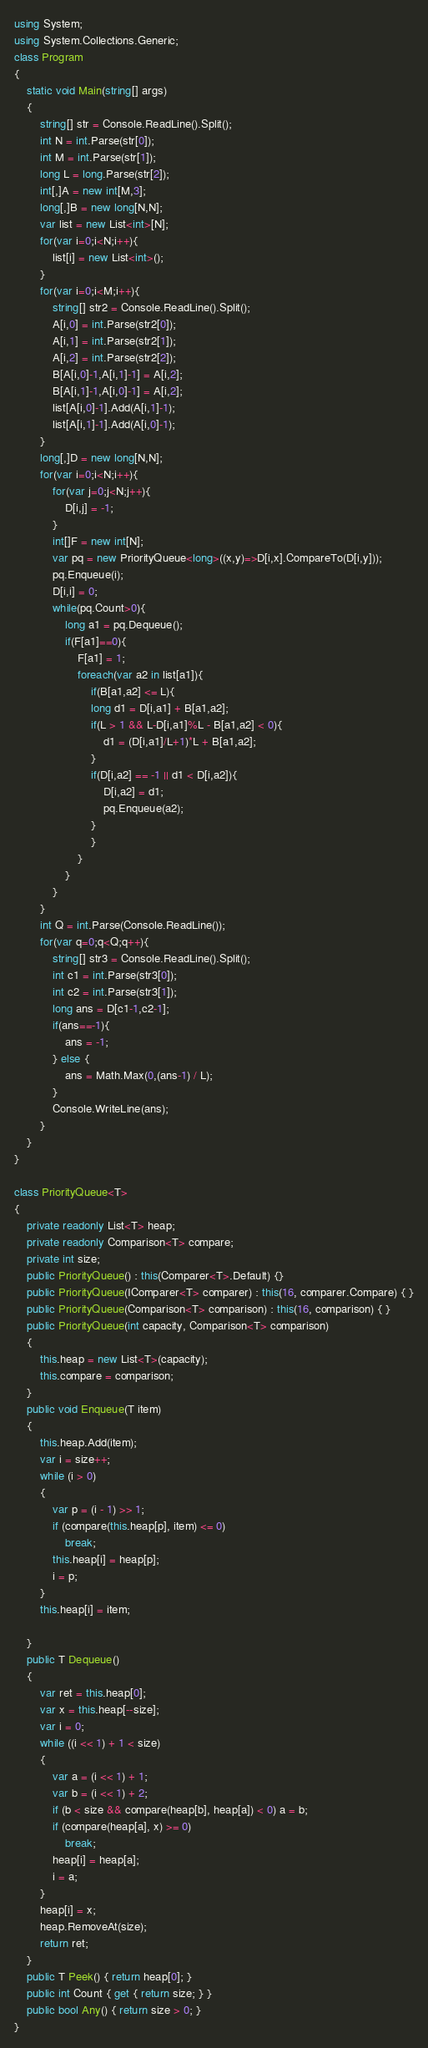Convert code to text. <code><loc_0><loc_0><loc_500><loc_500><_C#_>using System;
using System.Collections.Generic;
class Program
{
	static void Main(string[] args)
	{
		string[] str = Console.ReadLine().Split();
		int N = int.Parse(str[0]);
		int M = int.Parse(str[1]);
		long L = long.Parse(str[2]);
		int[,]A = new int[M,3];
		long[,]B = new long[N,N];
		var list = new List<int>[N];
		for(var i=0;i<N;i++){
			list[i] = new List<int>();
		}
		for(var i=0;i<M;i++){
			string[] str2 = Console.ReadLine().Split();
			A[i,0] = int.Parse(str2[0]);
			A[i,1] = int.Parse(str2[1]);
			A[i,2] = int.Parse(str2[2]);
			B[A[i,0]-1,A[i,1]-1] = A[i,2];
			B[A[i,1]-1,A[i,0]-1] = A[i,2];
			list[A[i,0]-1].Add(A[i,1]-1);
			list[A[i,1]-1].Add(A[i,0]-1);
		}
		long[,]D = new long[N,N];
		for(var i=0;i<N;i++){
			for(var j=0;j<N;j++){
				D[i,j] = -1;
			}
			int[]F = new int[N];
			var pq = new PriorityQueue<long>((x,y)=>D[i,x].CompareTo(D[i,y]));
			pq.Enqueue(i);
          	D[i,i] = 0;
			while(pq.Count>0){
				long a1 = pq.Dequeue();
				if(F[a1]==0){
					F[a1] = 1;
					foreach(var a2 in list[a1]){
						if(B[a1,a2] <= L){
                      	long d1 = D[i,a1] + B[a1,a2];
                      	if(L > 1 && L-D[i,a1]%L - B[a1,a2] < 0){
                         	d1 = (D[i,a1]/L+1)*L + B[a1,a2];
                        }
						if(D[i,a2] == -1 || d1 < D[i,a2]){
							D[i,a2] = d1;
							pq.Enqueue(a2);
						}
                        }
					}
				}
			}
		}
		int Q = int.Parse(Console.ReadLine());
		for(var q=0;q<Q;q++){
			string[] str3 = Console.ReadLine().Split();
			int c1 = int.Parse(str3[0]);
			int c2 = int.Parse(str3[1]);
			long ans = D[c1-1,c2-1];
			if(ans==-1){
				ans = -1;
			} else {
				ans = Math.Max(0,(ans-1) / L);
            }
			Console.WriteLine(ans);
		}
	}
}

class PriorityQueue<T>
{
    private readonly List<T> heap;
    private readonly Comparison<T> compare;
    private int size;
    public PriorityQueue() : this(Comparer<T>.Default) {} 
    public PriorityQueue(IComparer<T> comparer) : this(16, comparer.Compare) { }
    public PriorityQueue(Comparison<T> comparison) : this(16, comparison) { }
    public PriorityQueue(int capacity, Comparison<T> comparison)
    {
        this.heap = new List<T>(capacity);
        this.compare = comparison;
    }
    public void Enqueue(T item)
    {
        this.heap.Add(item);
        var i = size++;
        while (i > 0)
        {
            var p = (i - 1) >> 1;
            if (compare(this.heap[p], item) <= 0)
                break;
            this.heap[i] = heap[p];
            i = p;
        }
        this.heap[i] = item;

    }
    public T Dequeue()
    {
        var ret = this.heap[0];
        var x = this.heap[--size];
        var i = 0;
        while ((i << 1) + 1 < size)
        {
            var a = (i << 1) + 1;
            var b = (i << 1) + 2;
            if (b < size && compare(heap[b], heap[a]) < 0) a = b;
            if (compare(heap[a], x) >= 0)
                break;
            heap[i] = heap[a];
            i = a;
        }
        heap[i] = x;
        heap.RemoveAt(size);
        return ret;
    }
    public T Peek() { return heap[0]; }
    public int Count { get { return size; } }
    public bool Any() { return size > 0; }
}</code> 